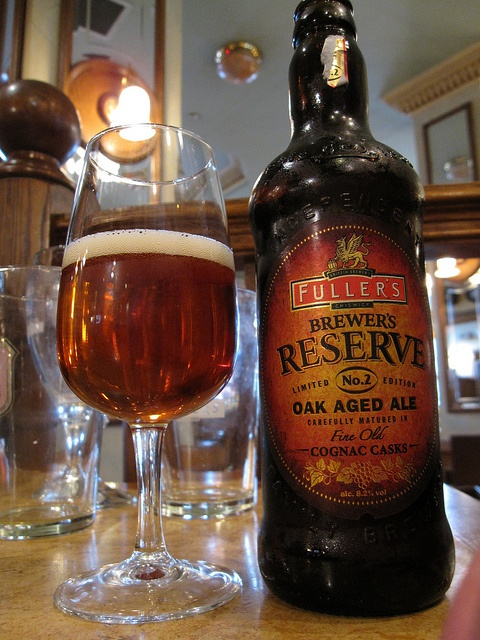Describe the objects in this image and their specific colors. I can see bottle in black, maroon, and brown tones, wine glass in black, maroon, darkgray, and gray tones, cup in black, gray, maroon, and darkgray tones, and cup in black, gray, darkgray, and maroon tones in this image. 